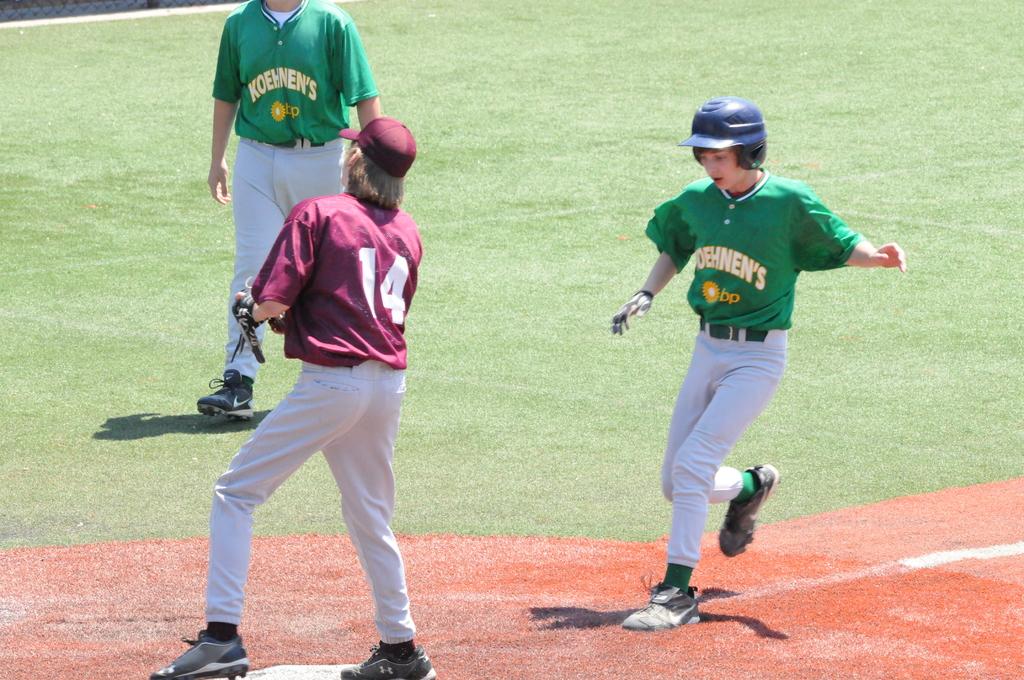What is the name of the team in the green jerseys?
Your answer should be compact. Koehnen's. What number is the player in the red jersey?
Your response must be concise. 14. 